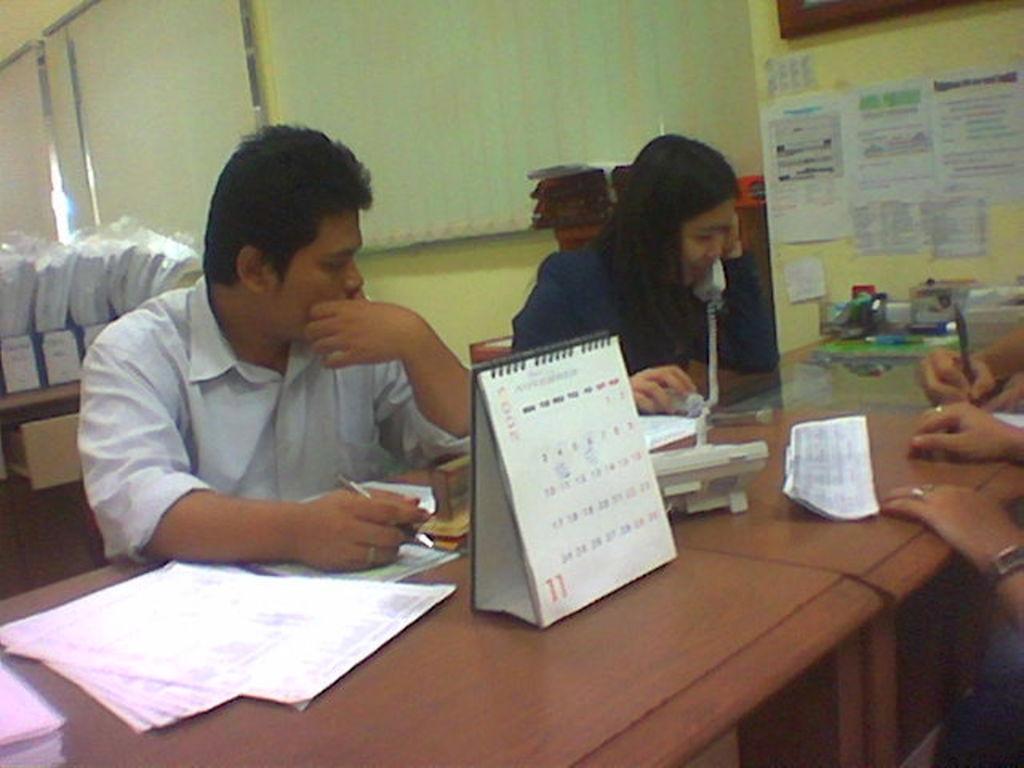Describe this image in one or two sentences. In this picture we can see group of people, they are all seated, in front of them we can see few papers, telephone and other things on the table, in the background we can find few files and window blinds. 